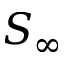Convert formula to latex. <formula><loc_0><loc_0><loc_500><loc_500>S _ { \infty }</formula> 